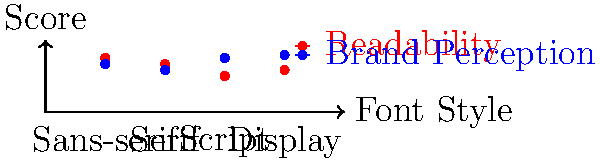Based on the graph showing the impact of different font styles on logo readability and brand perception, which font style would you recommend for a tech startup aiming to convey innovation while maintaining high readability? Explain your reasoning, considering the trade-offs between readability and brand perception. To answer this question, we need to analyze the graph and consider the requirements of a tech startup. Let's break down the process:

1. Understand the graph:
   - The x-axis represents different font styles: Sans-serif, Serif, Script, and Display.
   - The y-axis represents scores for readability (red dots) and brand perception (blue dots).
   - Higher scores indicate better performance in each category.

2. Analyze each font style:
   - Sans-serif: High readability (0.9), good brand perception (0.8)
   - Serif: Good readability (0.8), moderate brand perception (0.7)
   - Script: Low readability (0.6), high brand perception (0.9)
   - Display: Good readability (0.7), highest brand perception (0.95)

3. Consider the tech startup's needs:
   - Innovation: Requires a modern, forward-thinking appearance
   - High readability: Essential for clear communication

4. Evaluate the options:
   - Script and Display fonts have high brand perception but lower readability, which may not be suitable for a tech startup prioritizing clear communication.
   - Serif fonts, while readable, may appear too traditional for a tech startup aiming to convey innovation.
   - Sans-serif fonts offer the best balance of high readability and good brand perception.

5. Make a recommendation:
   - Sans-serif fonts would be the most appropriate choice for a tech startup aiming to convey innovation while maintaining high readability.
   - This style offers the highest readability score (0.9) and a strong brand perception score (0.8).
   - Sans-serif fonts are often associated with modernity and simplicity, aligning well with tech industry aesthetics.

6. Consider the trade-offs:
   - While Display fonts have a slightly higher brand perception score, the significant drop in readability makes them less suitable for this scenario.
   - The Sans-serif option provides the best balance between readability and brand perception, minimizing trade-offs.
Answer: Sans-serif fonts, balancing high readability (0.9) and strong brand perception (0.8) for tech innovation. 